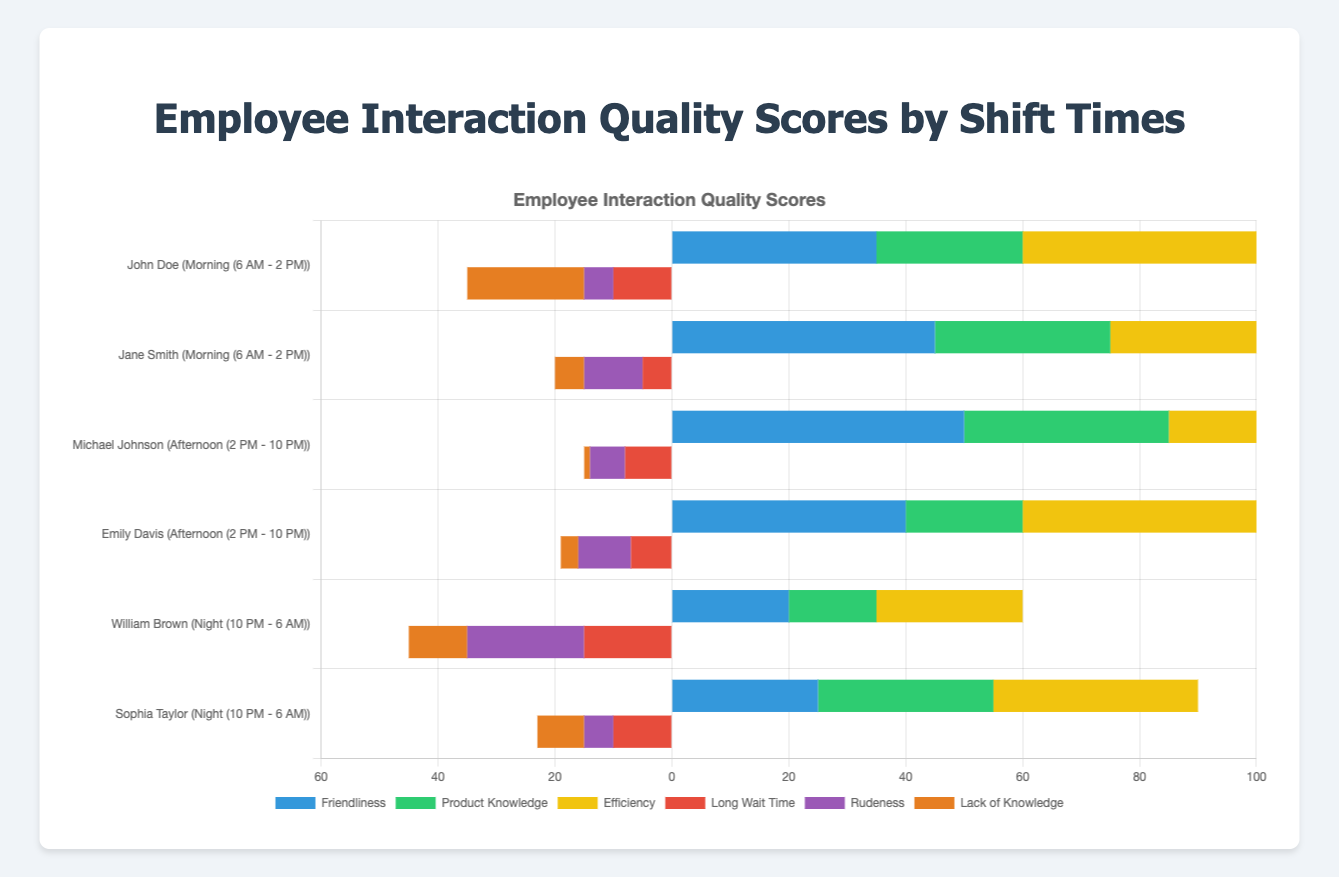What's the ratio of compliments to criticisms for Jane Smith? To find the ratio of compliments to criticisms for Jane Smith, add up her total compliments (45 Friendliness + 30 Product Knowledge + 25 Efficiency = 100) and criticisms (5 Long Wait Time + 10 Rudeness + 5 Lack of Knowledge = 20). The ratio is 100:20 or simplified, 5:1.
Answer: 5:1 Who received the highest number of total compliments during the afternoon shift? To find who received the highest total compliments in the afternoon shift, compare the totals of Michael Johnson (50 Friendliness + 35 Product Knowledge + 15 Efficiency = 100) and Emily Davis (40 Friendliness + 20 Product Knowledge + 40 Efficiency = 100). Both have 100 compliments, so they tie.
Answer: Michael Johnson and Emily Davis Which shift time had the lowest efficiency compliments? Compare the total efficiency compliments across all shift times: Morning ([John Doe 40] + [Jane Smith 25] = 65), Afternoon ([Michael Johnson 15] + [Emily Davis 40] = 55), and Night ([William Brown 25] + [Sophia Taylor 35] = 60). The afternoon shift has the lowest total efficiency compliments with 55.
Answer: Afternoon What is the difference in total criticisms between William Brown and John Doe? First, calculate William Brown's total criticisms (15 Long Wait Time + 20 Rudeness + 10 Lack of Knowledge = 45). Then, calculate John Doe's total criticisms (10 Long Wait Time + 5 Rudeness + 20 Lack of Knowledge = 35). The difference is 45 - 35 = 10.
Answer: 10 How many more compliments did John Doe receive for Friendliness than for Product Knowledge? John Doe received 35 compliments for Friendliness and 25 for Product Knowledge. The difference is 35 - 25 = 10.
Answer: 10 Which category has the most criticisms during the night shift? Sum the criticisms categories for the night shift employees: William Brown (15 Long Wait Time, 20 Rudeness, 10 Lack of Knowledge) and Sophia Taylor (10 Long Wait Time, 5 Rudeness, 8 Lack of Knowledge). The category with the highest total is Rudeness (20 + 5 = 25).
Answer: Rudeness Who had the highest total number of criticisms? Compare the total criticisms of each employee: John Doe (35), Jane Smith (20), Michael Johnson (15), Emily Davis (19), William Brown (45), Sophia Taylor (23). William Brown had the highest number with 45.
Answer: William Brown Calculate the average number of Product Knowledge compliments received by all employees. Sum all the Product Knowledge compliments (John Doe 25, Jane Smith 30, Michael Johnson 35, Emily Davis 20, William Brown 15, Sophia Taylor 30) which totals 155, and divide by the number of employees (6). So, 155 / 6 ≈ 25.83.
Answer: 25.83 Which employee during the morning shift received more compliments for Efficiency, and by how much? Compare John Doe's (40) and Jane Smith's (25) Efficiency compliments. John Doe received 40 - 25 = 15 more compliments for Efficiency.
Answer: John Doe by 15 What is the overall trend in criticisms for Long Wait Time across all shifts? Sum Long Wait Time criticisms for all shifts: Morning (10+5=15), Afternoon (8+7=15), and Night (15+10=25). The trend shows that Long Wait Time criticisms increase from morning/afternoon to night.
Answer: Increase to night 